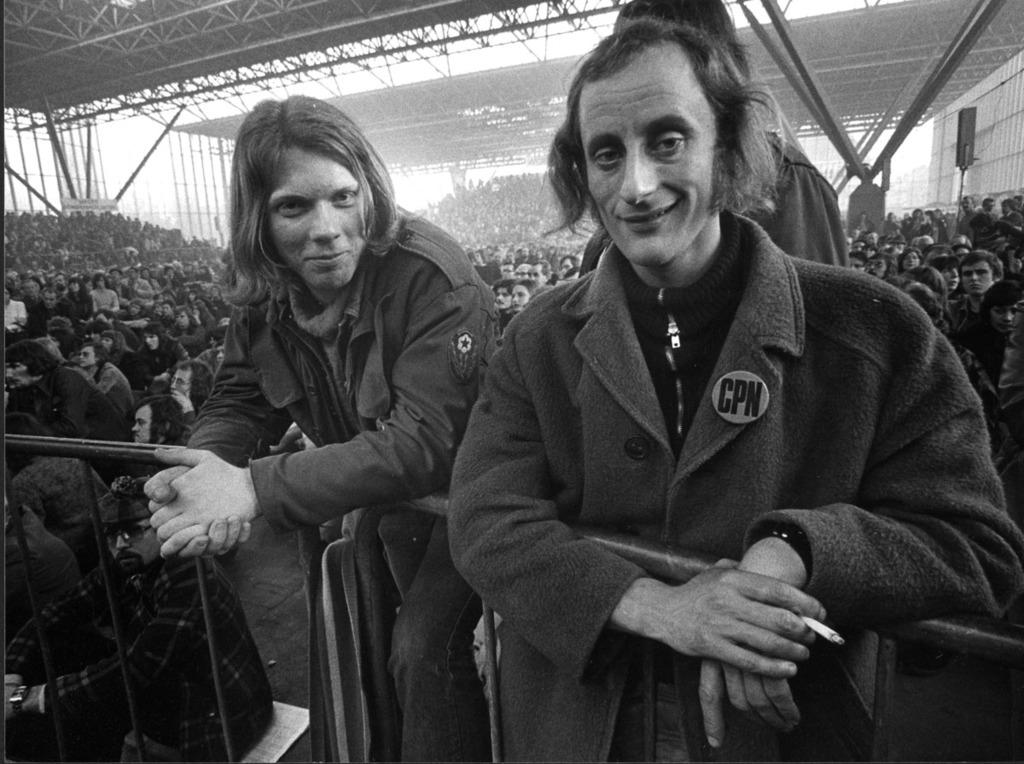How many men are in the image? There are two men standing in the image. What is the facial expression of the men? The men are smiling. What can be seen in the background of the image? There is a group of people, shelters, a banner, and a speaker visible in the background. What type of airplane is the uncle flying in the image? There is no airplane or uncle present in the image. What is the answer to the question that the speaker is asking in the image? The image does not provide any information about a question being asked or an answer being given. 